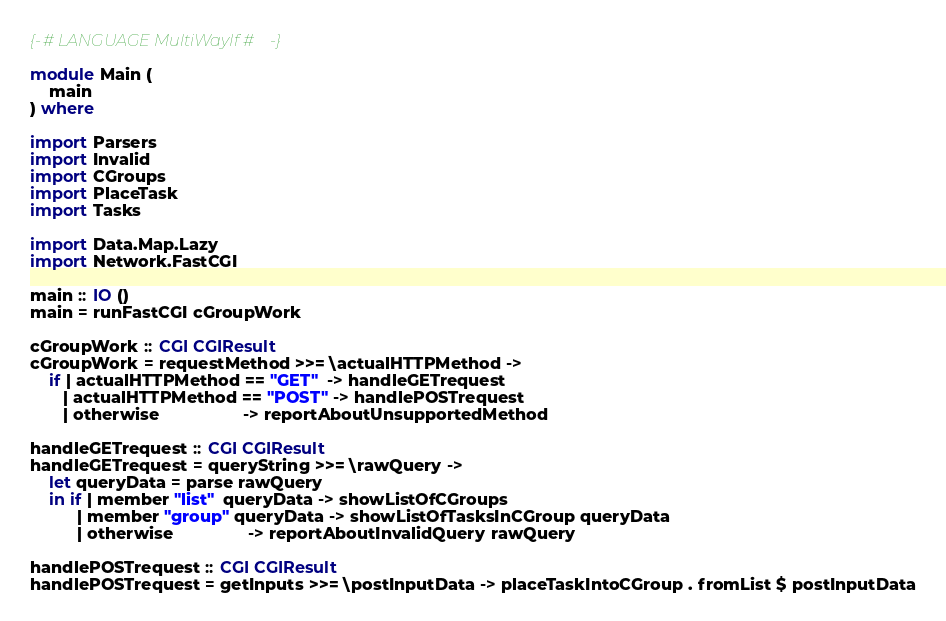Convert code to text. <code><loc_0><loc_0><loc_500><loc_500><_Haskell_>{-# LANGUAGE MultiWayIf #-}

module Main (
    main
) where

import Parsers
import Invalid
import CGroups
import PlaceTask
import Tasks

import Data.Map.Lazy      
import Network.FastCGI

main :: IO ()
main = runFastCGI cGroupWork

cGroupWork :: CGI CGIResult
cGroupWork = requestMethod >>= \actualHTTPMethod ->
    if | actualHTTPMethod == "GET"  -> handleGETrequest
       | actualHTTPMethod == "POST" -> handlePOSTrequest
       | otherwise                  -> reportAboutUnsupportedMethod

handleGETrequest :: CGI CGIResult
handleGETrequest = queryString >>= \rawQuery ->
    let queryData = parse rawQuery
    in if | member "list"  queryData -> showListOfCGroups
          | member "group" queryData -> showListOfTasksInCGroup queryData
          | otherwise                -> reportAboutInvalidQuery rawQuery

handlePOSTrequest :: CGI CGIResult
handlePOSTrequest = getInputs >>= \postInputData -> placeTaskIntoCGroup . fromList $ postInputData
</code> 